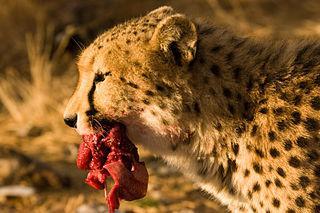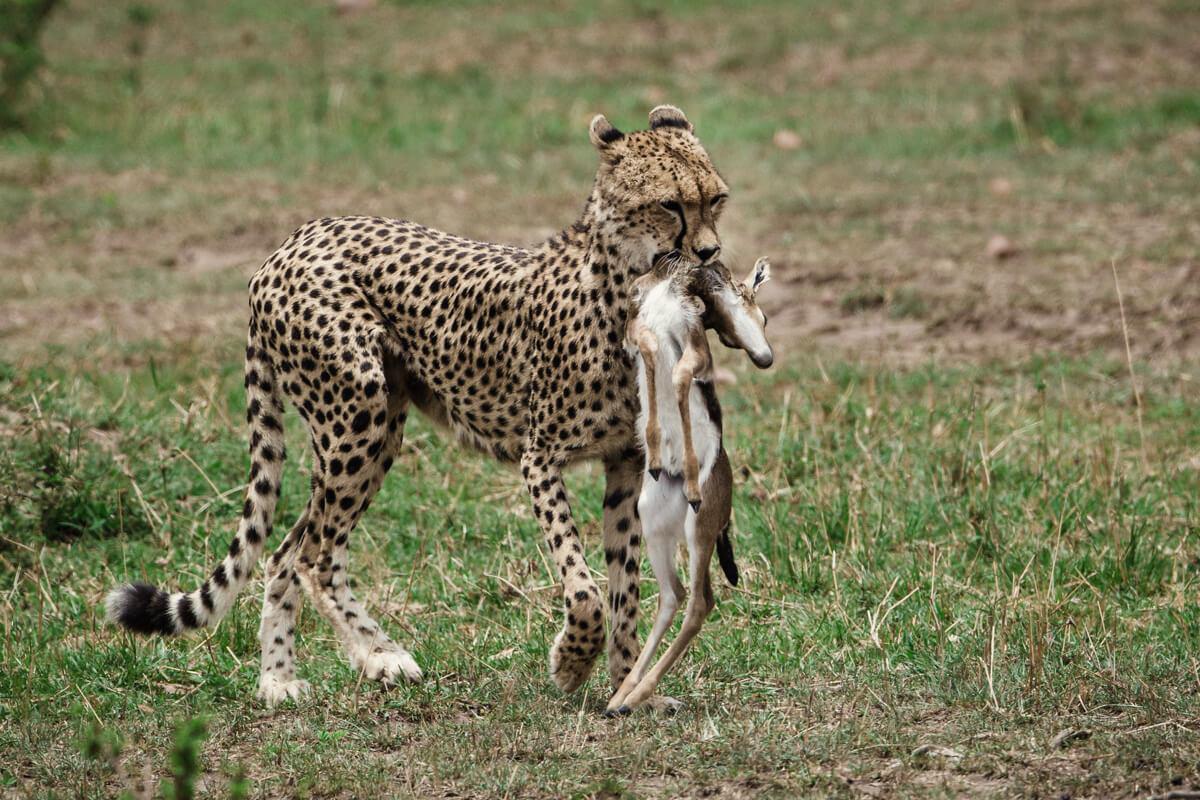The first image is the image on the left, the second image is the image on the right. For the images shown, is this caption "One image shows a reclining adult spotted wild cat posed with a cub." true? Answer yes or no. No. The first image is the image on the left, the second image is the image on the right. For the images displayed, is the sentence "In one of the images there are two cheetahs laying next to each other." factually correct? Answer yes or no. No. 